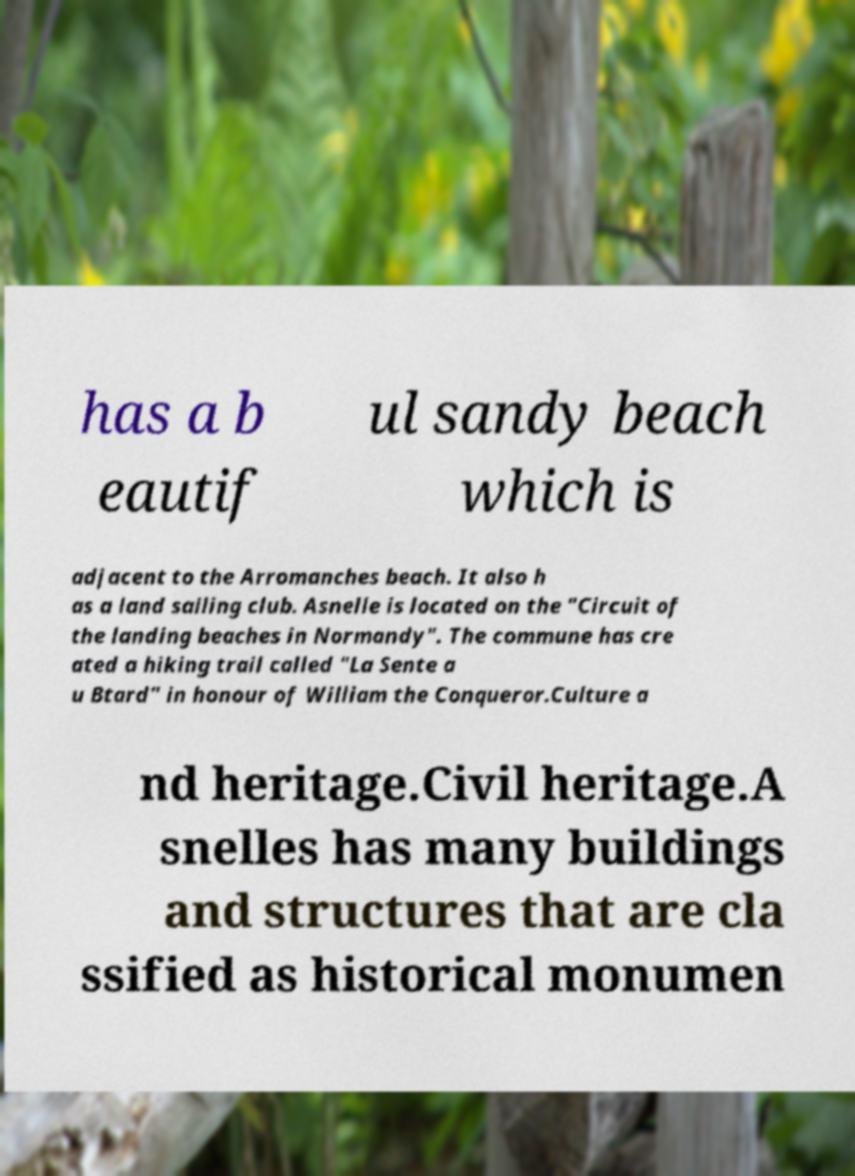For documentation purposes, I need the text within this image transcribed. Could you provide that? has a b eautif ul sandy beach which is adjacent to the Arromanches beach. It also h as a land sailing club. Asnelle is located on the "Circuit of the landing beaches in Normandy". The commune has cre ated a hiking trail called "La Sente a u Btard" in honour of William the Conqueror.Culture a nd heritage.Civil heritage.A snelles has many buildings and structures that are cla ssified as historical monumen 